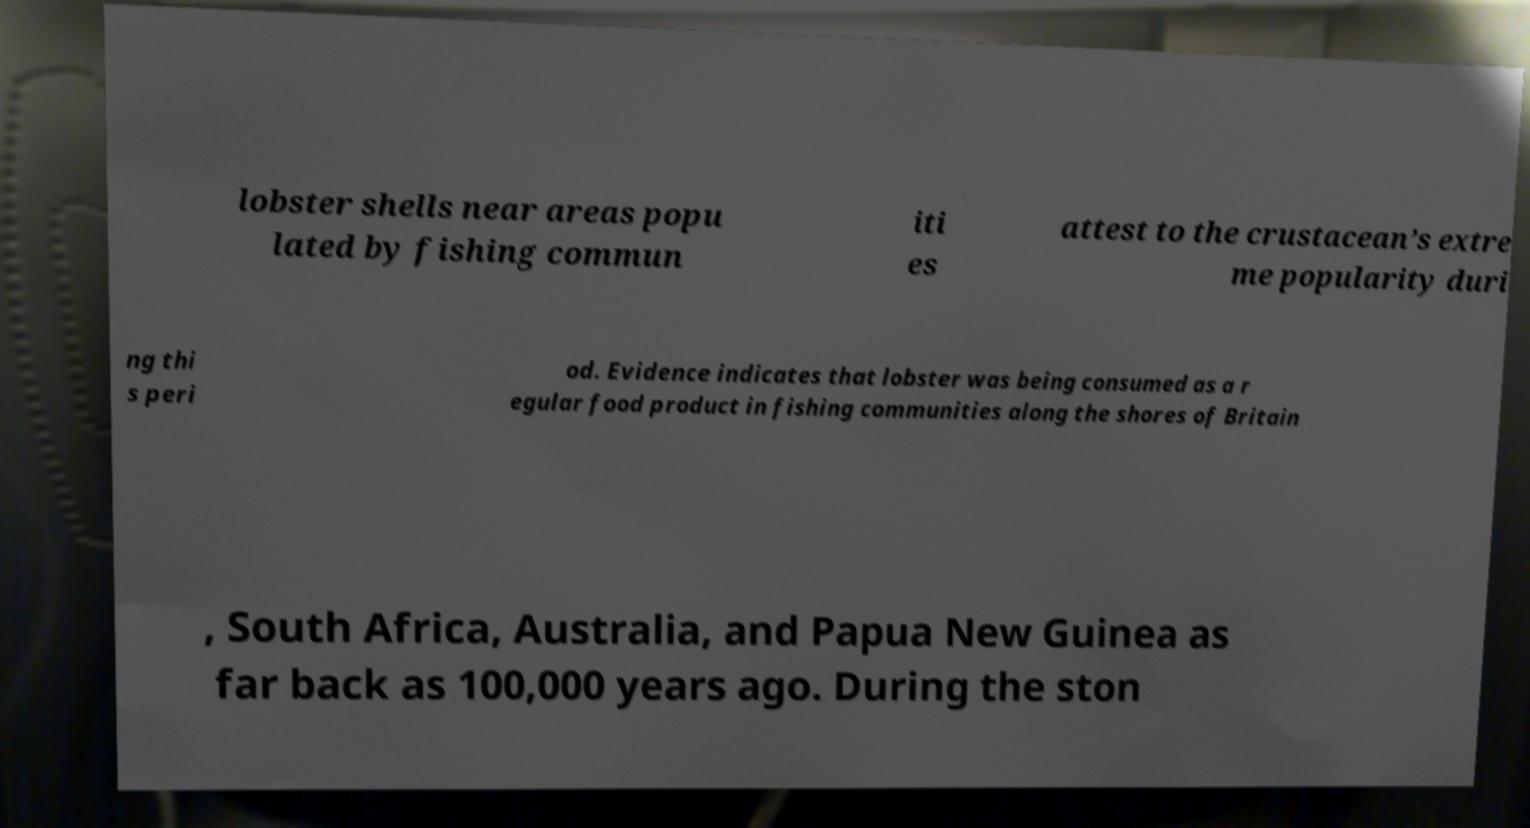Can you accurately transcribe the text from the provided image for me? lobster shells near areas popu lated by fishing commun iti es attest to the crustacean’s extre me popularity duri ng thi s peri od. Evidence indicates that lobster was being consumed as a r egular food product in fishing communities along the shores of Britain , South Africa, Australia, and Papua New Guinea as far back as 100,000 years ago. During the ston 